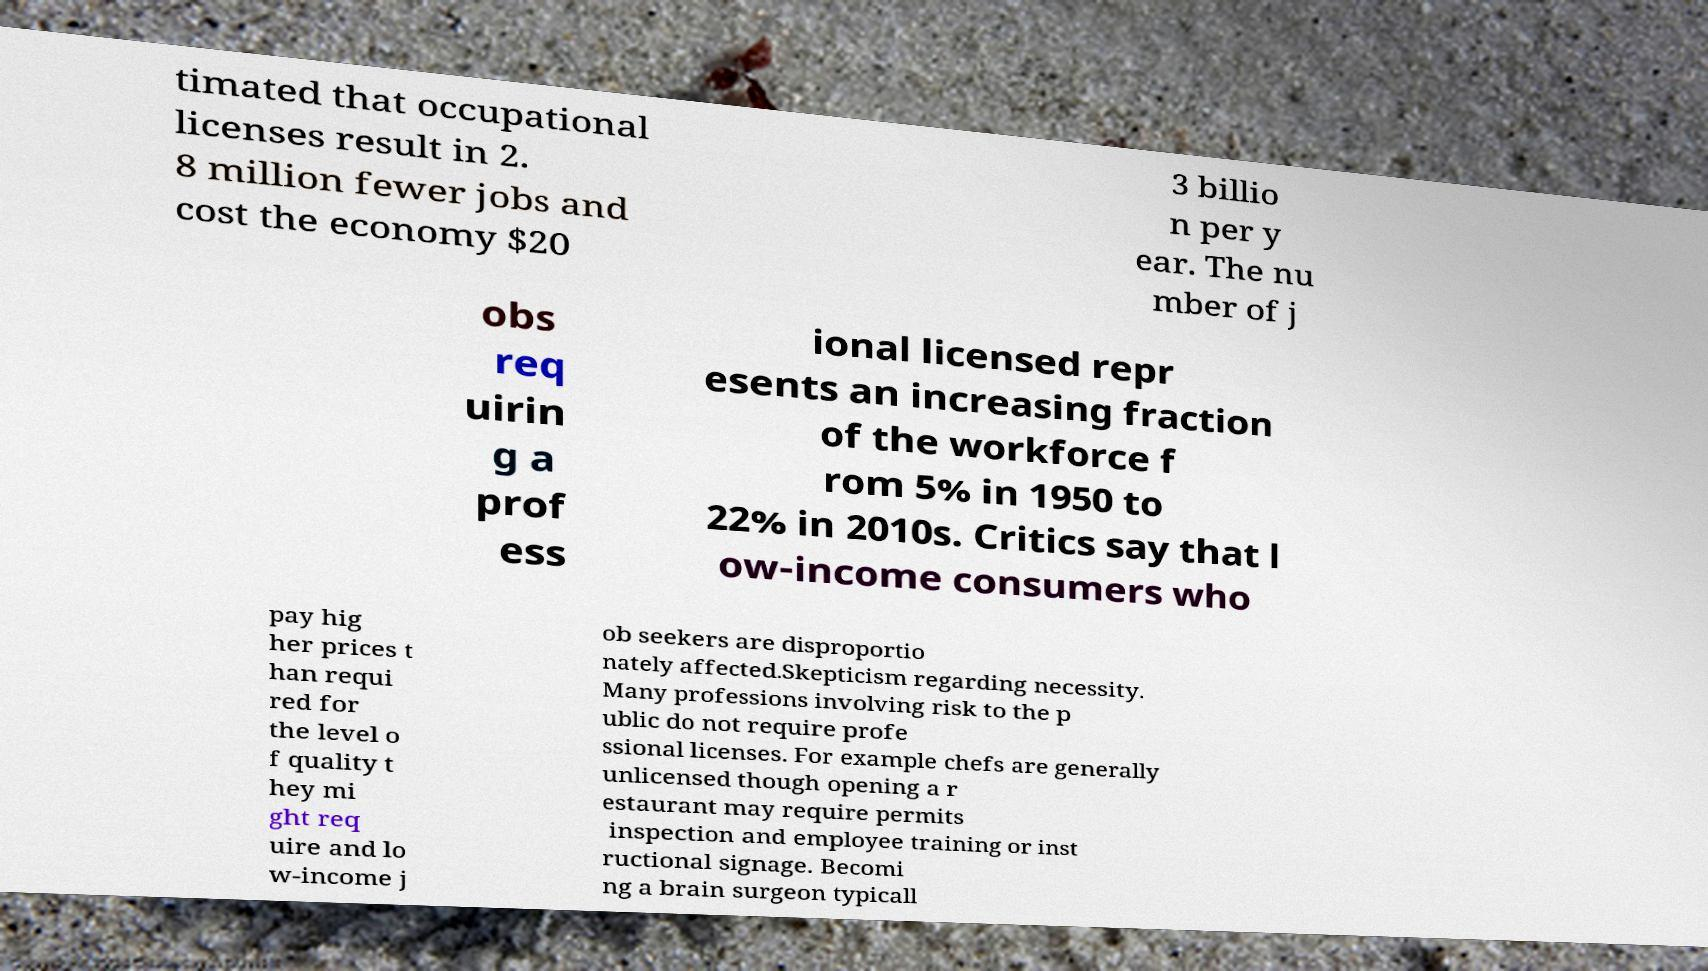Please identify and transcribe the text found in this image. timated that occupational licenses result in 2. 8 million fewer jobs and cost the economy $20 3 billio n per y ear. The nu mber of j obs req uirin g a prof ess ional licensed repr esents an increasing fraction of the workforce f rom 5% in 1950 to 22% in 2010s. Critics say that l ow-income consumers who pay hig her prices t han requi red for the level o f quality t hey mi ght req uire and lo w-income j ob seekers are disproportio nately affected.Skepticism regarding necessity. Many professions involving risk to the p ublic do not require profe ssional licenses. For example chefs are generally unlicensed though opening a r estaurant may require permits inspection and employee training or inst ructional signage. Becomi ng a brain surgeon typicall 